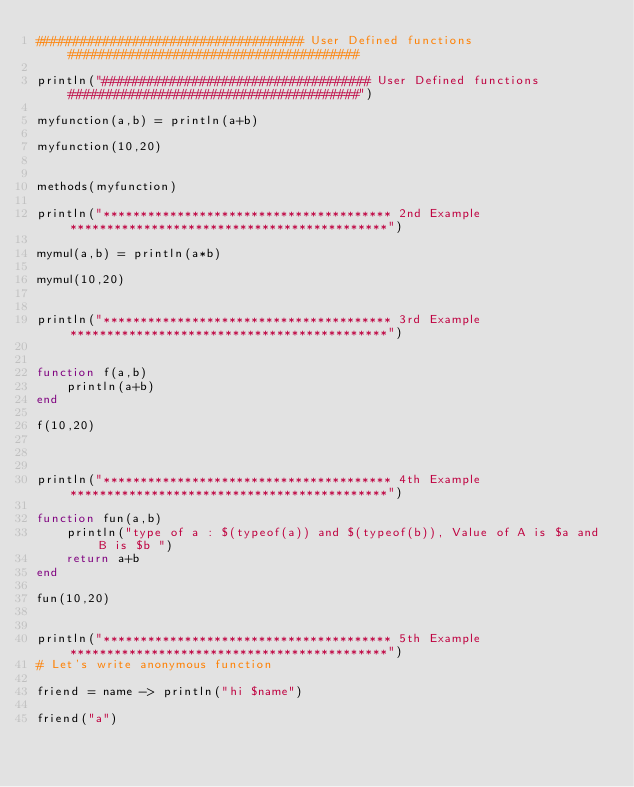<code> <loc_0><loc_0><loc_500><loc_500><_Julia_>#################################### User Defined functions #######################################

println("#################################### User Defined functions #######################################")

myfunction(a,b) = println(a+b)

myfunction(10,20)


methods(myfunction)

println("*************************************** 2nd Example *******************************************")

mymul(a,b) = println(a*b)

mymul(10,20)


println("*************************************** 3rd Example *******************************************")


function f(a,b)
    println(a+b)
end

f(10,20)



println("*************************************** 4th Example *******************************************")

function fun(a,b)
    println("type of a : $(typeof(a)) and $(typeof(b)), Value of A is $a and B is $b ")
    return a+b
end

fun(10,20)


println("*************************************** 5th Example *******************************************")
# Let's write anonymous function

friend = name -> println("hi $name")

friend("a")
</code> 